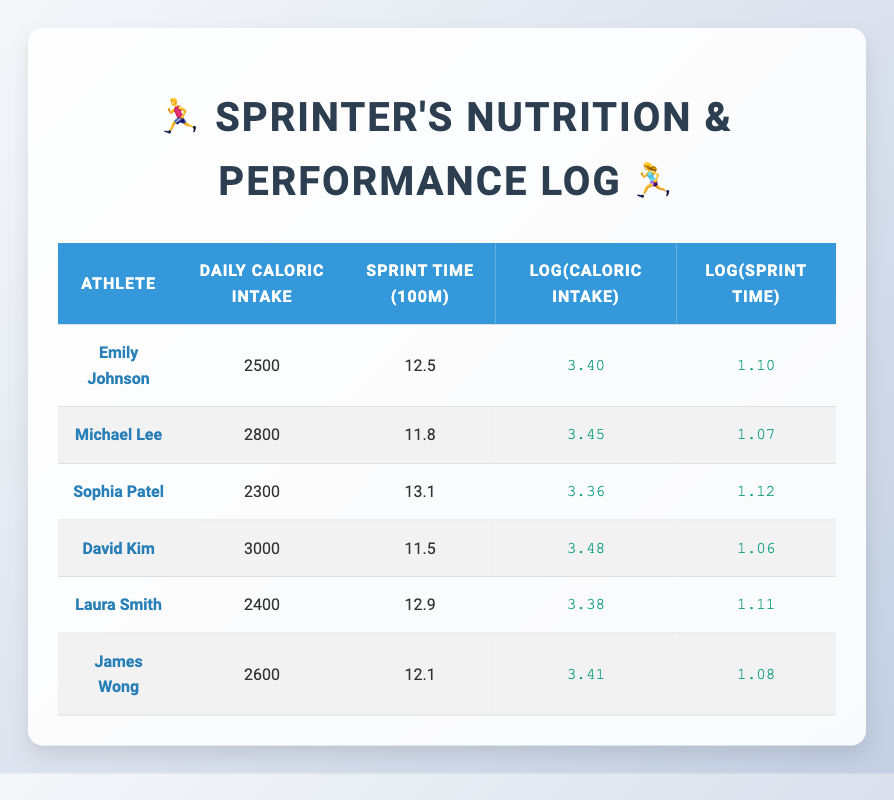What is the daily caloric intake of Michael Lee? The table lists Michael Lee's daily caloric intake, which is directly presented as 2800.
Answer: 2800 Which athlete has the best sprint time for the 100m? David Kim has the fastest sprint time of 11.5, which is lower than the sprint times of the other athletes listed.
Answer: David Kim What is the average daily caloric intake among all athletes? To find the average, we must sum the daily caloric intakes of all athletes: (2500 + 2800 + 2300 + 3000 + 2400 + 2600) = 18600. Then divide by the number of athletes (6): 18600 / 6 = 3100.
Answer: 3100 Is Emily Johnson's sprint time faster than Sophia Patel's? Emily Johnson has a sprint time of 12.5, while Sophia Patel has a sprint time of 13.1. Since 12.5 is lower than 13.1, Emily Johnson is indeed faster.
Answer: Yes What is the difference in sprint time between David Kim and Michael Lee? David Kim's sprint time is 11.5, and Michael Lee's sprint time is 11.8. To find the difference, we subtract: 11.8 - 11.5 = 0.3, indicating that David Kim is faster by this amount.
Answer: 0.3 seconds What is the relationship between caloric intake and sprint times observed in this table? Analyzing the data, as daily caloric intake increases, the sprint times generally decrease, suggesting that higher caloric intake may be associated with better performance (shorter sprint times). However, thorough statistical analysis would be needed to confirm this hypothesis.
Answer: Generally inversely related Is the average sprint time greater than 12 seconds? First, we calculate the average sprint time: (12.5 + 11.8 + 13.1 + 11.5 + 12.9 + 12.1) = 73.9. Then we divide by the number of athletes: 73.9 / 6 = 12.32, which is greater than 12.
Answer: Yes Which athlete has the highest log value of sprint time? The log values of the sprint times are: Emily Johnson (1.10), Michael Lee (1.07), Sophia Patel (1.12), David Kim (1.06), Laura Smith (1.11), and James Wong (1.08). The highest log value is 1.12 for Sophia Patel.
Answer: Sophia Patel If an athlete had a daily caloric intake of 2700, how would it compare logarithmically to the athletes present? The logarithm of 2700 can be calculated as approximately 3.43. Comparing with those in the table, it is higher than Emily Johnson (3.40) and lower than David Kim (3.48), Michael Lee (3.45), and higher than Laura Smith (3.38) and James Wong (3.41). So, it would fall in the middle range.
Answer: In the middle range 